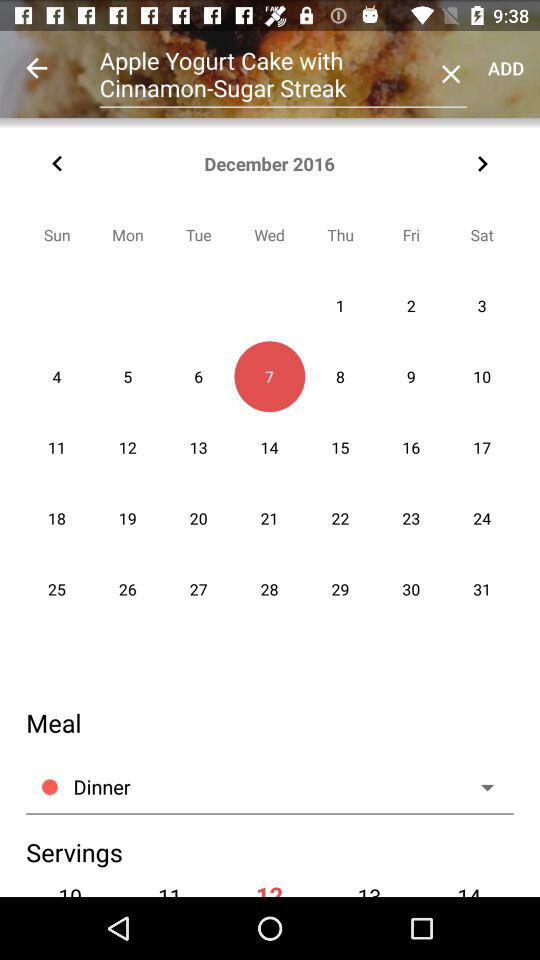What is the given year? The given year is 2016. 